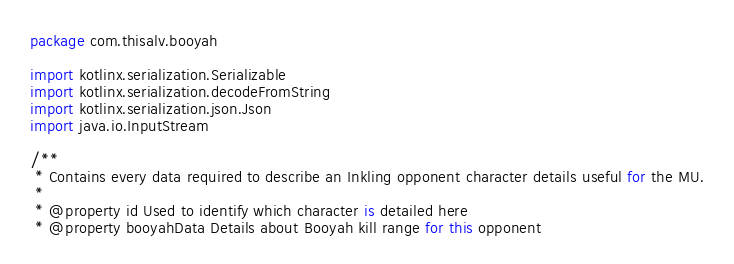Convert code to text. <code><loc_0><loc_0><loc_500><loc_500><_Kotlin_>package com.thisalv.booyah

import kotlinx.serialization.Serializable
import kotlinx.serialization.decodeFromString
import kotlinx.serialization.json.Json
import java.io.InputStream

/**
 * Contains every data required to describe an Inkling opponent character details useful for the MU.
 *
 * @property id Used to identify which character is detailed here
 * @property booyahData Details about Booyah kill range for this opponent</code> 